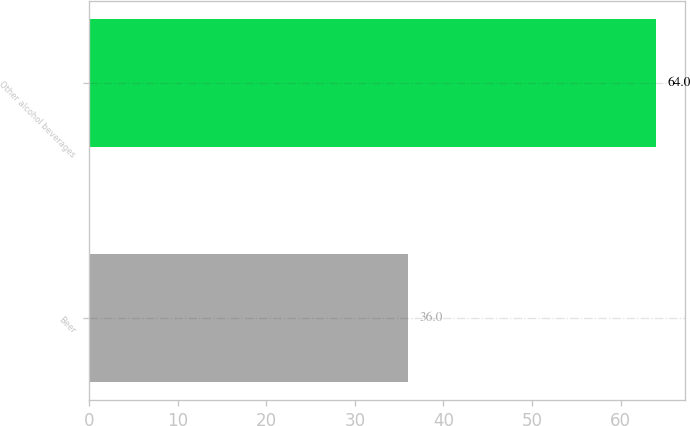Convert chart. <chart><loc_0><loc_0><loc_500><loc_500><bar_chart><fcel>Beer<fcel>Other alcohol beverages<nl><fcel>36<fcel>64<nl></chart> 